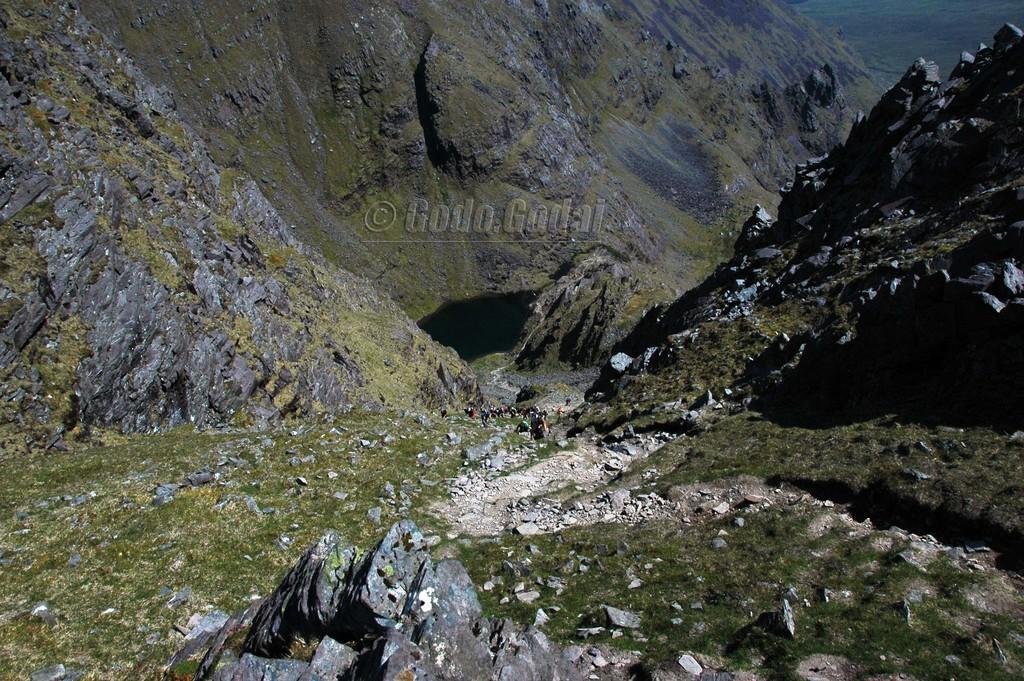Describe this image in one or two sentences. In this image, we can see hills, stones, grass. In the middle of the image, we can see few people and watermark. 